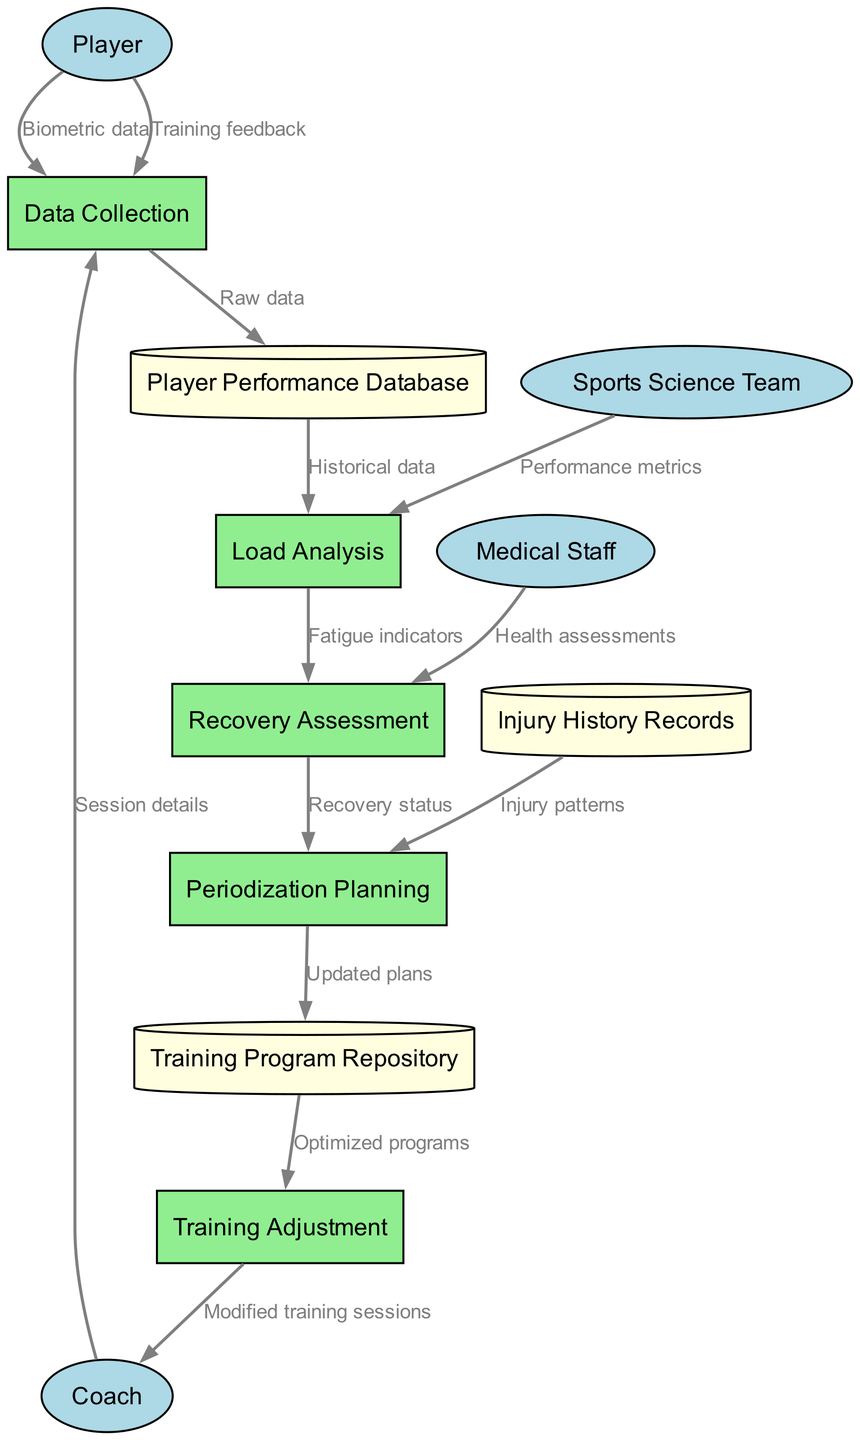What are the external entities involved in the system? The external entities are listed in the diagram as nodes that interact with the processes. They include 'Player', 'Coach', 'Sports Science Team', and 'Medical Staff'.
Answer: Player, Coach, Sports Science Team, Medical Staff How many processes are defined in the diagram? The number of processes can be counted by identifying all the labeled rectangles in the diagram. There are five processes specified: 'Data Collection', 'Load Analysis', 'Recovery Assessment', 'Periodization Planning', and 'Training Adjustment'.
Answer: 5 What type of data does a player provide to 'Data Collection'? By examining the labeled edges connecting 'Player' to 'Data Collection', we see that the data consists of 'Biometric data' and 'Training feedback'.
Answer: Biometric data, Training feedback Which process follows 'Load Analysis'? The diagram illustrates a directional flow from 'Load Analysis' to 'Recovery Assessment'. Hence, the process that follows 'Load Analysis' is 'Recovery Assessment'.
Answer: Recovery Assessment What is the role of the Medical Staff in the system? The Medical Staff interacts with the 'Recovery Assessment' process, where they provide 'Health assessments'. This indicates their role in monitoring player health and recovery.
Answer: Health assessments How many data stores are represented in the diagram? The diagram shows three distinct data stores labeled as 'Player Performance Database', 'Training Program Repository', and 'Injury History Records'. Each of these is represented as a cylinder.
Answer: 3 What information does 'Recovery Assessment' send to 'Periodization Planning'? According to the data flow, 'Recovery Assessment' sends 'Recovery status' to 'Periodization Planning', indicating the assessment of recovery status informs the planning phase.
Answer: Recovery status Which external entity contributes performance metrics to 'Load Analysis'? The flow indicates that the 'Sports Science Team' provides 'Performance metrics' to 'Load Analysis', which highlights their contribution to the analytical process.
Answer: Sports Science Team What data does 'Periodization Planning' output to 'Training Program Repository'? The output from 'Periodization Planning' is 'Updated plans', which are stored in the 'Training Program Repository' for further use in training adjustments.
Answer: Updated plans 